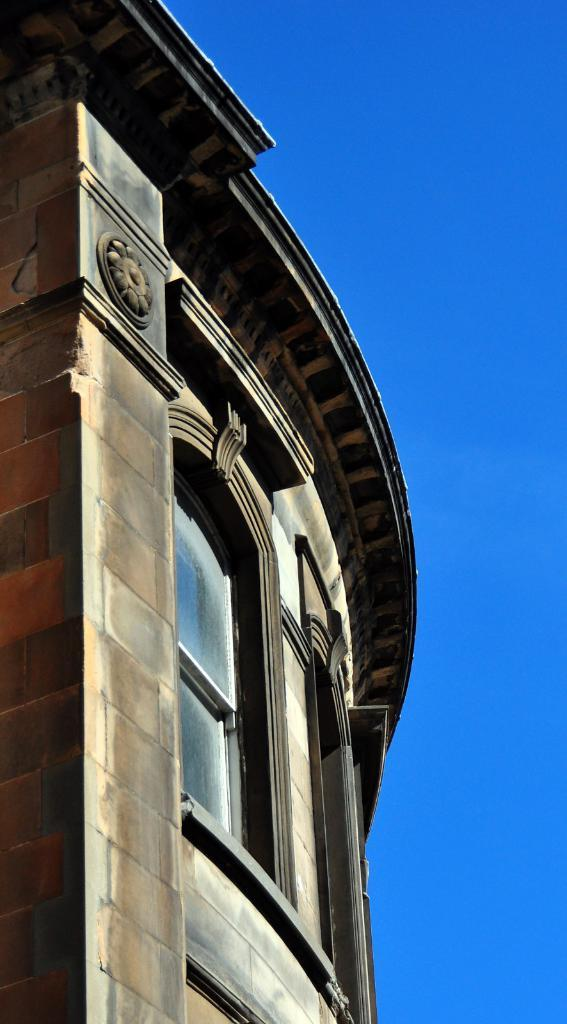What is the main structure in the picture? There is a building in the picture. What part of the sky can be seen in the picture? The sky is visible on the left side of the picture. What feature can be observed in the center of the building? There are windows in the center of the building. What letters are written on the calendar in the picture? There is no calendar present in the picture, so it is not possible to answer that question. 